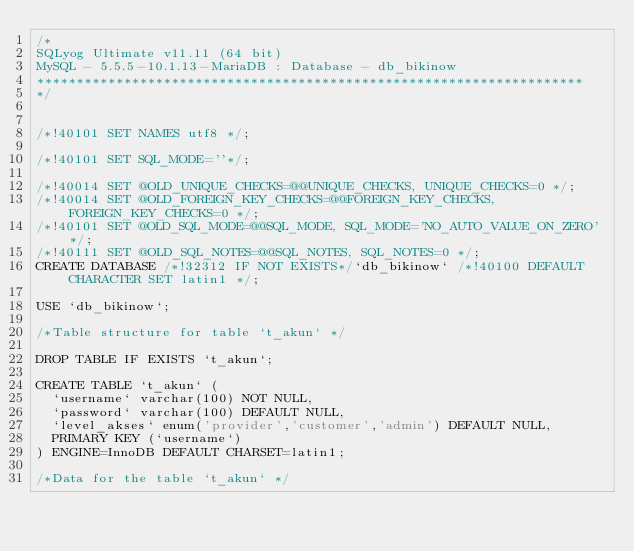<code> <loc_0><loc_0><loc_500><loc_500><_SQL_>/*
SQLyog Ultimate v11.11 (64 bit)
MySQL - 5.5.5-10.1.13-MariaDB : Database - db_bikinow
*********************************************************************
*/

/*!40101 SET NAMES utf8 */;

/*!40101 SET SQL_MODE=''*/;

/*!40014 SET @OLD_UNIQUE_CHECKS=@@UNIQUE_CHECKS, UNIQUE_CHECKS=0 */;
/*!40014 SET @OLD_FOREIGN_KEY_CHECKS=@@FOREIGN_KEY_CHECKS, FOREIGN_KEY_CHECKS=0 */;
/*!40101 SET @OLD_SQL_MODE=@@SQL_MODE, SQL_MODE='NO_AUTO_VALUE_ON_ZERO' */;
/*!40111 SET @OLD_SQL_NOTES=@@SQL_NOTES, SQL_NOTES=0 */;
CREATE DATABASE /*!32312 IF NOT EXISTS*/`db_bikinow` /*!40100 DEFAULT CHARACTER SET latin1 */;

USE `db_bikinow`;

/*Table structure for table `t_akun` */

DROP TABLE IF EXISTS `t_akun`;

CREATE TABLE `t_akun` (
  `username` varchar(100) NOT NULL,
  `password` varchar(100) DEFAULT NULL,
  `level_akses` enum('provider','customer','admin') DEFAULT NULL,
  PRIMARY KEY (`username`)
) ENGINE=InnoDB DEFAULT CHARSET=latin1;

/*Data for the table `t_akun` */
</code> 